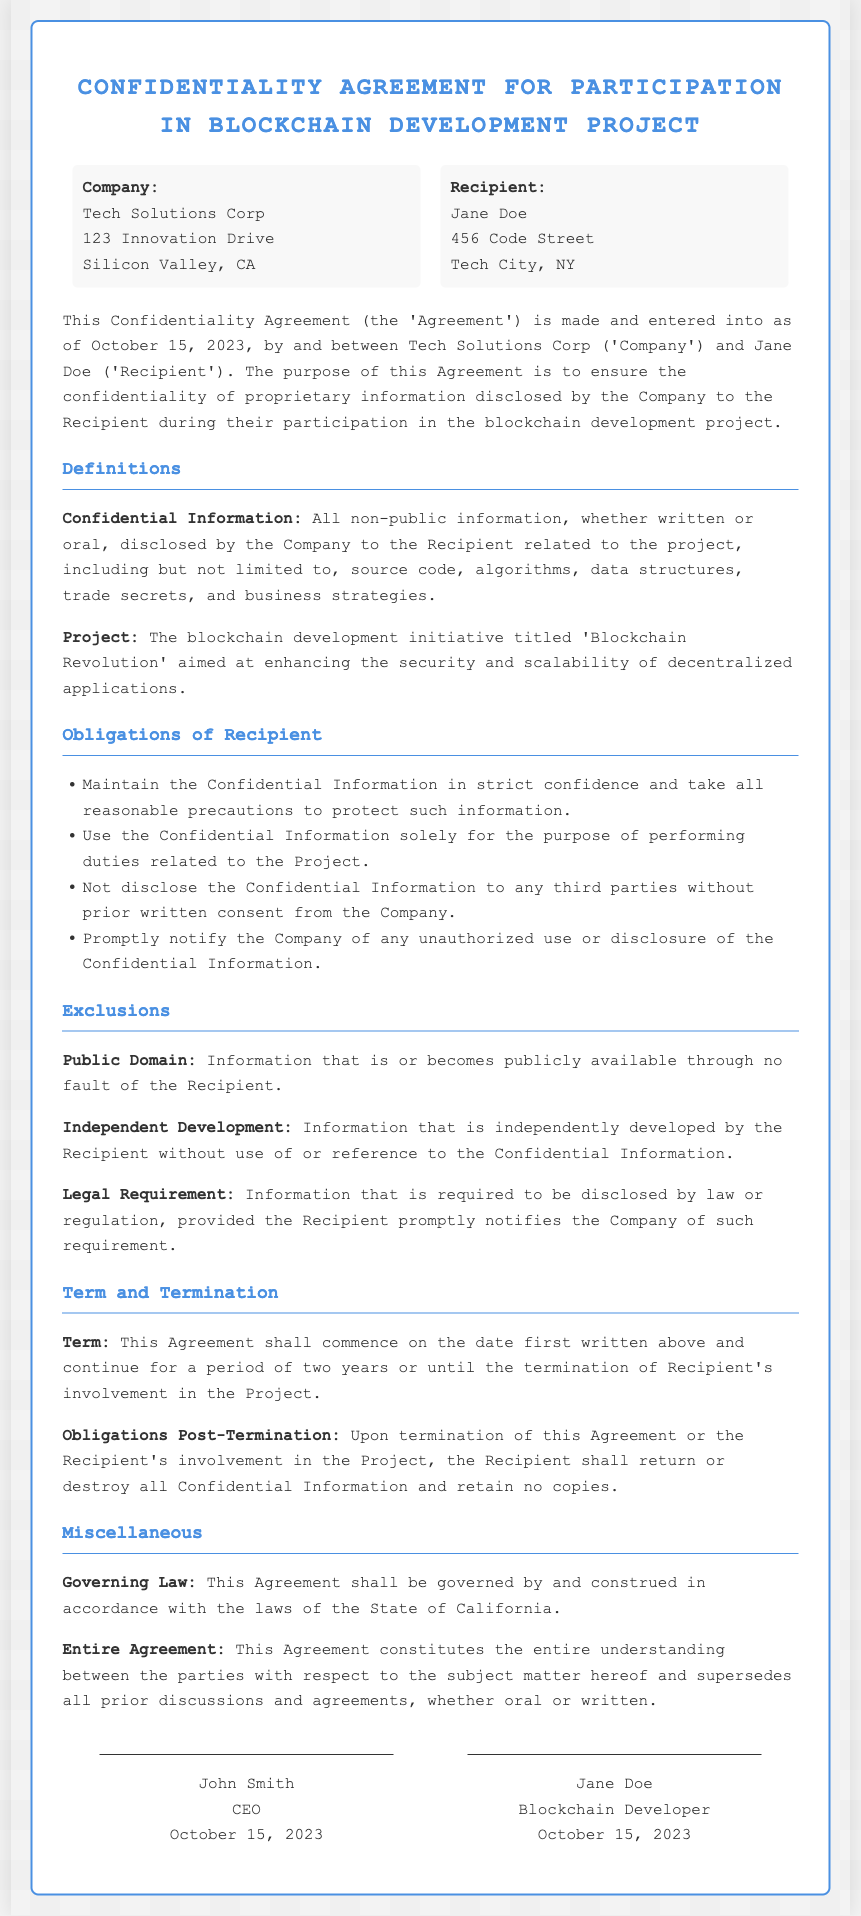What is the name of the company? The name of the company is specified at the beginning of the document as "Tech Solutions Corp".
Answer: Tech Solutions Corp Who is the recipient of the agreement? The document specifies the recipient as "Jane Doe".
Answer: Jane Doe What is the date the agreement was made? The date when the agreement was entered into is highlighted in the document as "October 15, 2023".
Answer: October 15, 2023 What is the term duration of the agreement? The duration of the agreement is specified to last for "two years".
Answer: two years What is the purpose of the confidentiality agreement? The purpose of the agreement is clearly stated as ensuring the confidentiality of proprietary information disclosed.
Answer: confidentiality of proprietary information Under what law is this agreement governed? The governing law for this agreement is indicated in the document as "the laws of the State of California".
Answer: the laws of the State of California What should the recipient do upon termination of the agreement? Upon termination, the recipient is required to "return or destroy all Confidential Information".
Answer: return or destroy all Confidential Information What is considered as Confidential Information? Confidential Information includes "all non-public information...related to the project".
Answer: all non-public information How many signatures are required on the agreement? The document shows that there are "two signatures" present in the signatures section.
Answer: two signatures 